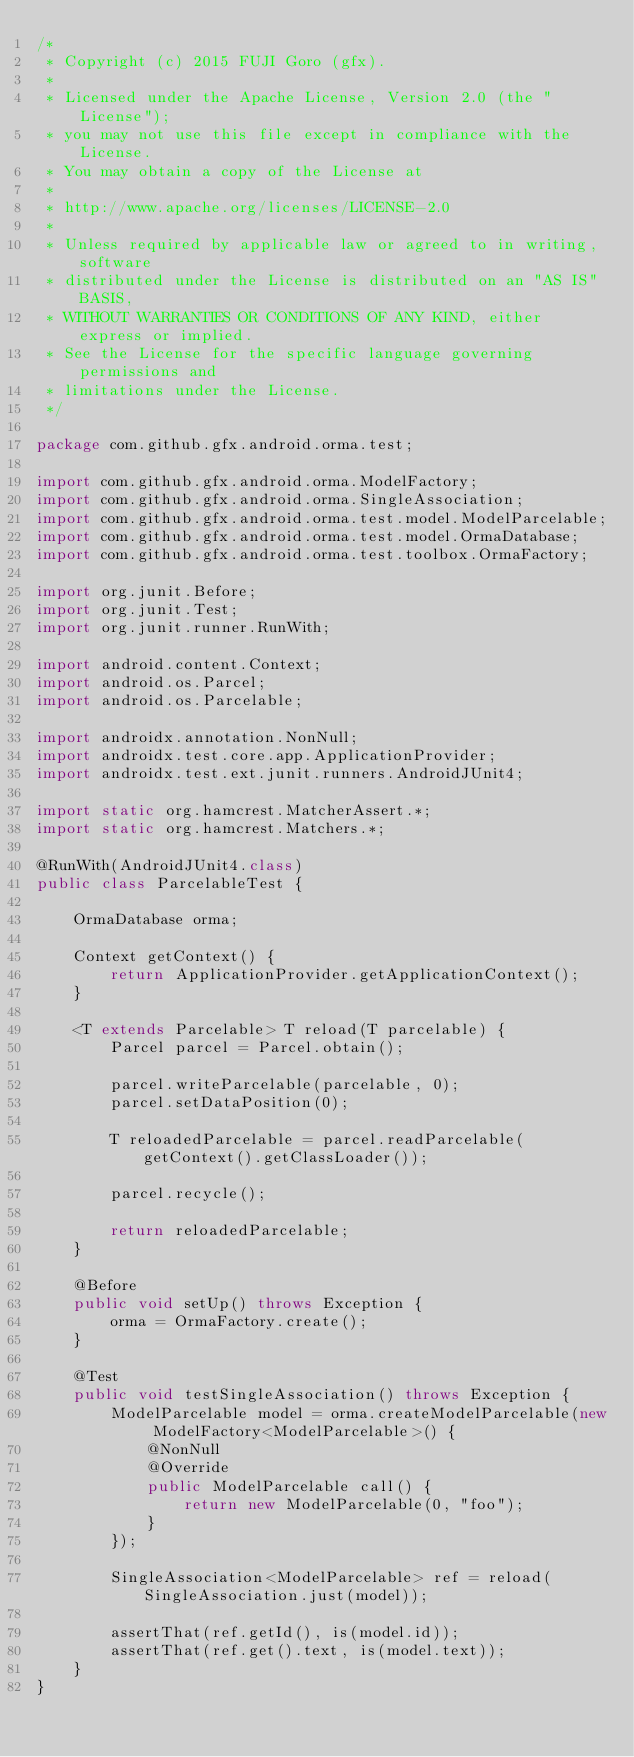Convert code to text. <code><loc_0><loc_0><loc_500><loc_500><_Java_>/*
 * Copyright (c) 2015 FUJI Goro (gfx).
 *
 * Licensed under the Apache License, Version 2.0 (the "License");
 * you may not use this file except in compliance with the License.
 * You may obtain a copy of the License at
 *
 * http://www.apache.org/licenses/LICENSE-2.0
 *
 * Unless required by applicable law or agreed to in writing, software
 * distributed under the License is distributed on an "AS IS" BASIS,
 * WITHOUT WARRANTIES OR CONDITIONS OF ANY KIND, either express or implied.
 * See the License for the specific language governing permissions and
 * limitations under the License.
 */

package com.github.gfx.android.orma.test;

import com.github.gfx.android.orma.ModelFactory;
import com.github.gfx.android.orma.SingleAssociation;
import com.github.gfx.android.orma.test.model.ModelParcelable;
import com.github.gfx.android.orma.test.model.OrmaDatabase;
import com.github.gfx.android.orma.test.toolbox.OrmaFactory;

import org.junit.Before;
import org.junit.Test;
import org.junit.runner.RunWith;

import android.content.Context;
import android.os.Parcel;
import android.os.Parcelable;

import androidx.annotation.NonNull;
import androidx.test.core.app.ApplicationProvider;
import androidx.test.ext.junit.runners.AndroidJUnit4;

import static org.hamcrest.MatcherAssert.*;
import static org.hamcrest.Matchers.*;

@RunWith(AndroidJUnit4.class)
public class ParcelableTest {

    OrmaDatabase orma;

    Context getContext() {
        return ApplicationProvider.getApplicationContext();
    }

    <T extends Parcelable> T reload(T parcelable) {
        Parcel parcel = Parcel.obtain();

        parcel.writeParcelable(parcelable, 0);
        parcel.setDataPosition(0);

        T reloadedParcelable = parcel.readParcelable(getContext().getClassLoader());

        parcel.recycle();

        return reloadedParcelable;
    }

    @Before
    public void setUp() throws Exception {
        orma = OrmaFactory.create();
    }

    @Test
    public void testSingleAssociation() throws Exception {
        ModelParcelable model = orma.createModelParcelable(new ModelFactory<ModelParcelable>() {
            @NonNull
            @Override
            public ModelParcelable call() {
                return new ModelParcelable(0, "foo");
            }
        });

        SingleAssociation<ModelParcelable> ref = reload(SingleAssociation.just(model));

        assertThat(ref.getId(), is(model.id));
        assertThat(ref.get().text, is(model.text));
    }
}
</code> 